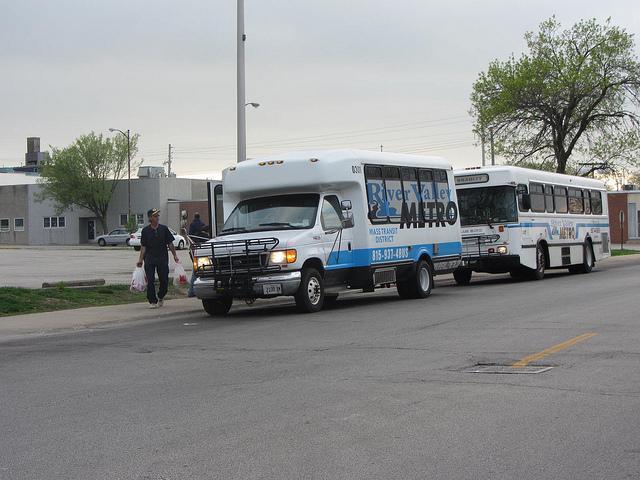How many trucks are there?
Give a very brief answer. 2. How many buses are on this road?
Give a very brief answer. 2. How many buses are there?
Give a very brief answer. 2. How many people can be seen?
Give a very brief answer. 2. How many buses can be seen?
Give a very brief answer. 2. 